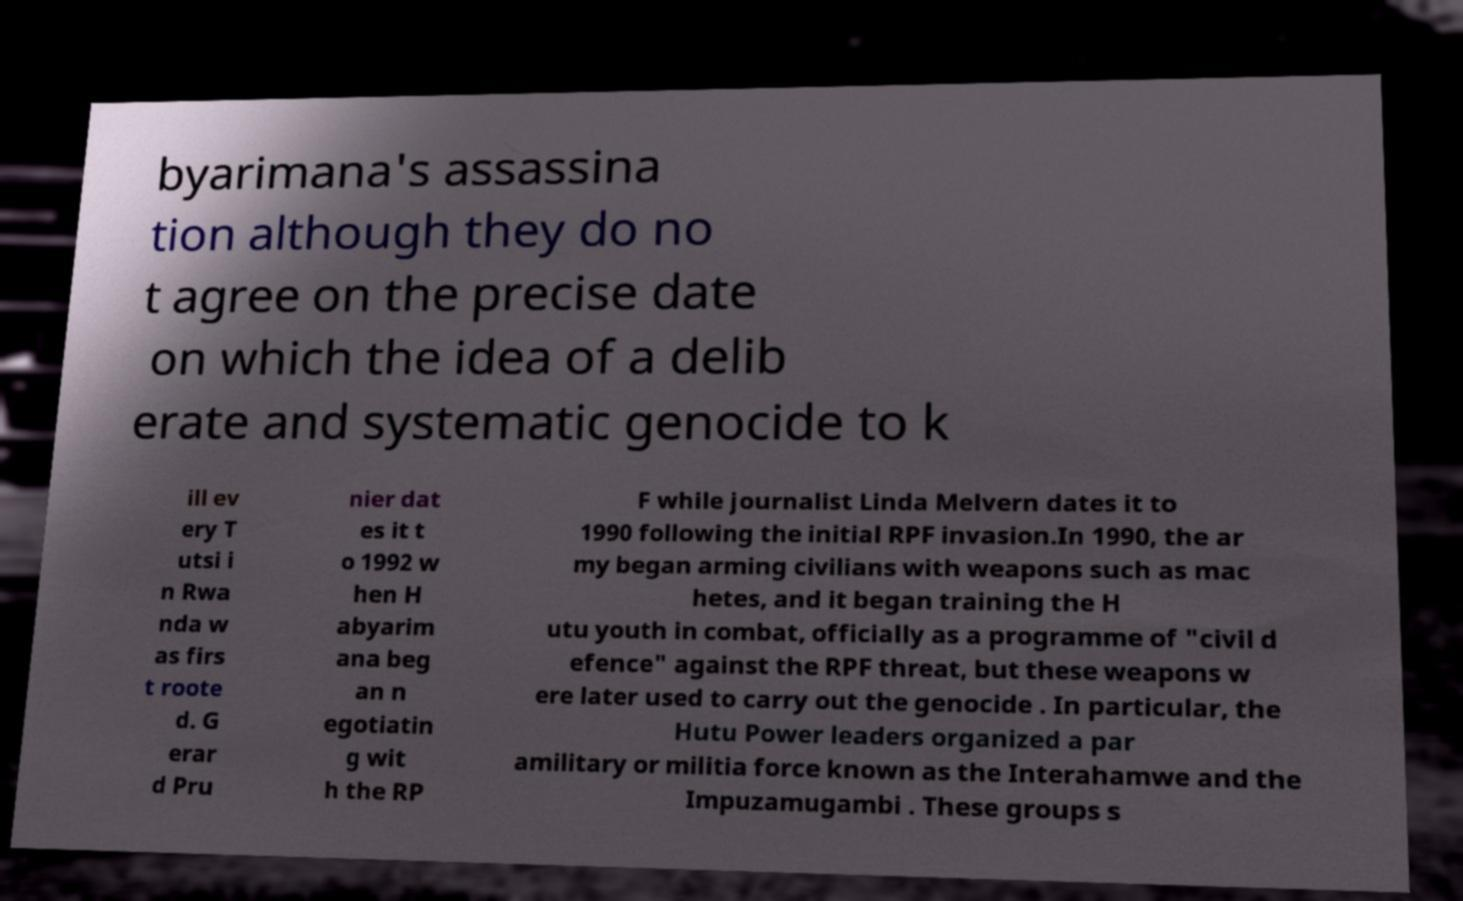For documentation purposes, I need the text within this image transcribed. Could you provide that? byarimana's assassina tion although they do no t agree on the precise date on which the idea of a delib erate and systematic genocide to k ill ev ery T utsi i n Rwa nda w as firs t roote d. G erar d Pru nier dat es it t o 1992 w hen H abyarim ana beg an n egotiatin g wit h the RP F while journalist Linda Melvern dates it to 1990 following the initial RPF invasion.In 1990, the ar my began arming civilians with weapons such as mac hetes, and it began training the H utu youth in combat, officially as a programme of "civil d efence" against the RPF threat, but these weapons w ere later used to carry out the genocide . In particular, the Hutu Power leaders organized a par amilitary or militia force known as the Interahamwe and the Impuzamugambi . These groups s 